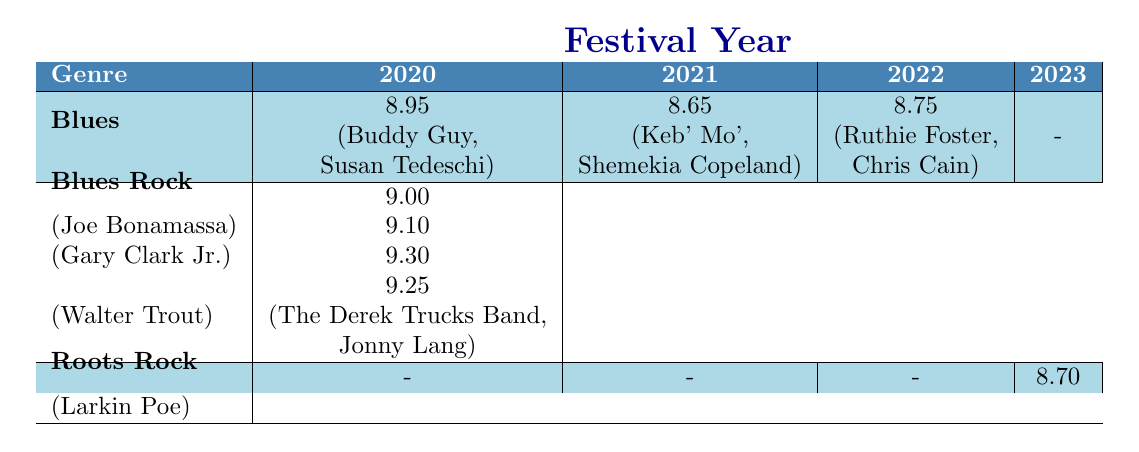What was the performance rating of Buddy Guy in 2020? According to the table, Buddy Guy performed in 2020 and had a performance rating of 9.2.
Answer: 9.2 What is the average performance rating for the Blues genre in 2021? The performance ratings for the Blues genre in 2021 are 8.8 (Keb' Mo') and 8.5 (Shemekia Copeland). The average is calculated as (8.8 + 8.5) / 2 = 8.65.
Answer: 8.65 Was there a performance rating for the Roots Rock genre in 2020? In the table, there are no ratings listed for the Roots Rock genre in 2020. Therefore, the answer is no.
Answer: No Which genre had the highest average performance rating in 2022? The average for Blues is (8.9 + 8.6) / 2 = 8.75 and for Blues Rock, the rating is 9.3 (Walter Trout) in 2022. Thus, Blues Rock has a higher average than Blues.
Answer: Blues Rock In which festival year was the highest performance rating recorded for the Blues Rock genre? The highest performance rating for Blues Rock is 9.5, found in the year 2023 (The Derek Trucks Band).
Answer: 2023 What is the difference between the average performance ratings of Blues and Blues Rock genres in 2020? The average for Blues in 2020 is (8.95) and for Blues Rock, it is 9. The difference is 9 - 8.95 = 0.05.
Answer: 0.05 Did any artist from the Blues genre perform rated below 9.0 in 2023? The Blues genre has no ratings in 2023, so it is impossible to have artists rated below 9.0. Hence, the answer is no.
Answer: No Which artist had the best performance rating across all years in the Blues Rock genre? The highest rating in Blues Rock is 9.5 from The Derek Trucks Band in 2023.
Answer: The Derek Trucks Band What is the total number of Blues artists that performed in the festival across all years? The total count of Blues artists is 5 (Buddy Guy, Susan Tedeschi, Keb' Mo', Shemekia Copeland, Ruthie Foster, Chris Cain).
Answer: 5 